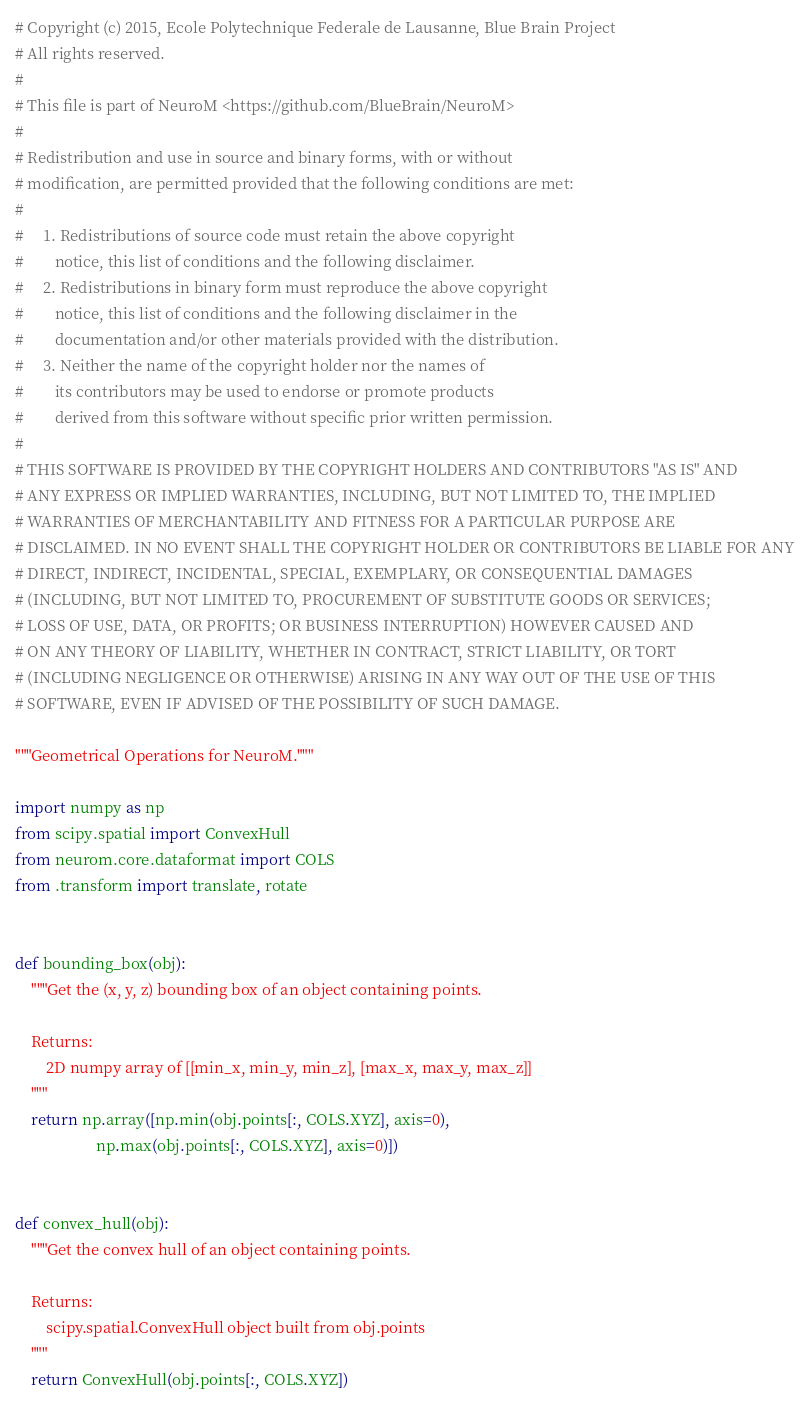Convert code to text. <code><loc_0><loc_0><loc_500><loc_500><_Python_># Copyright (c) 2015, Ecole Polytechnique Federale de Lausanne, Blue Brain Project
# All rights reserved.
#
# This file is part of NeuroM <https://github.com/BlueBrain/NeuroM>
#
# Redistribution and use in source and binary forms, with or without
# modification, are permitted provided that the following conditions are met:
#
#     1. Redistributions of source code must retain the above copyright
#        notice, this list of conditions and the following disclaimer.
#     2. Redistributions in binary form must reproduce the above copyright
#        notice, this list of conditions and the following disclaimer in the
#        documentation and/or other materials provided with the distribution.
#     3. Neither the name of the copyright holder nor the names of
#        its contributors may be used to endorse or promote products
#        derived from this software without specific prior written permission.
#
# THIS SOFTWARE IS PROVIDED BY THE COPYRIGHT HOLDERS AND CONTRIBUTORS "AS IS" AND
# ANY EXPRESS OR IMPLIED WARRANTIES, INCLUDING, BUT NOT LIMITED TO, THE IMPLIED
# WARRANTIES OF MERCHANTABILITY AND FITNESS FOR A PARTICULAR PURPOSE ARE
# DISCLAIMED. IN NO EVENT SHALL THE COPYRIGHT HOLDER OR CONTRIBUTORS BE LIABLE FOR ANY
# DIRECT, INDIRECT, INCIDENTAL, SPECIAL, EXEMPLARY, OR CONSEQUENTIAL DAMAGES
# (INCLUDING, BUT NOT LIMITED TO, PROCUREMENT OF SUBSTITUTE GOODS OR SERVICES;
# LOSS OF USE, DATA, OR PROFITS; OR BUSINESS INTERRUPTION) HOWEVER CAUSED AND
# ON ANY THEORY OF LIABILITY, WHETHER IN CONTRACT, STRICT LIABILITY, OR TORT
# (INCLUDING NEGLIGENCE OR OTHERWISE) ARISING IN ANY WAY OUT OF THE USE OF THIS
# SOFTWARE, EVEN IF ADVISED OF THE POSSIBILITY OF SUCH DAMAGE.

"""Geometrical Operations for NeuroM."""

import numpy as np
from scipy.spatial import ConvexHull
from neurom.core.dataformat import COLS
from .transform import translate, rotate


def bounding_box(obj):
    """Get the (x, y, z) bounding box of an object containing points.

    Returns:
        2D numpy array of [[min_x, min_y, min_z], [max_x, max_y, max_z]]
    """
    return np.array([np.min(obj.points[:, COLS.XYZ], axis=0),
                     np.max(obj.points[:, COLS.XYZ], axis=0)])


def convex_hull(obj):
    """Get the convex hull of an object containing points.

    Returns:
        scipy.spatial.ConvexHull object built from obj.points
    """
    return ConvexHull(obj.points[:, COLS.XYZ])
</code> 